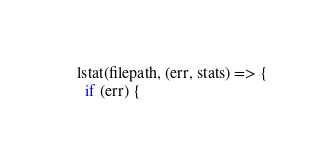Convert code to text. <code><loc_0><loc_0><loc_500><loc_500><_TypeScript_>    lstat(filepath, (err, stats) => {
      if (err) {</code> 